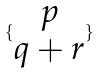Convert formula to latex. <formula><loc_0><loc_0><loc_500><loc_500>\{ \begin{matrix} p \\ q + r \end{matrix} \}</formula> 